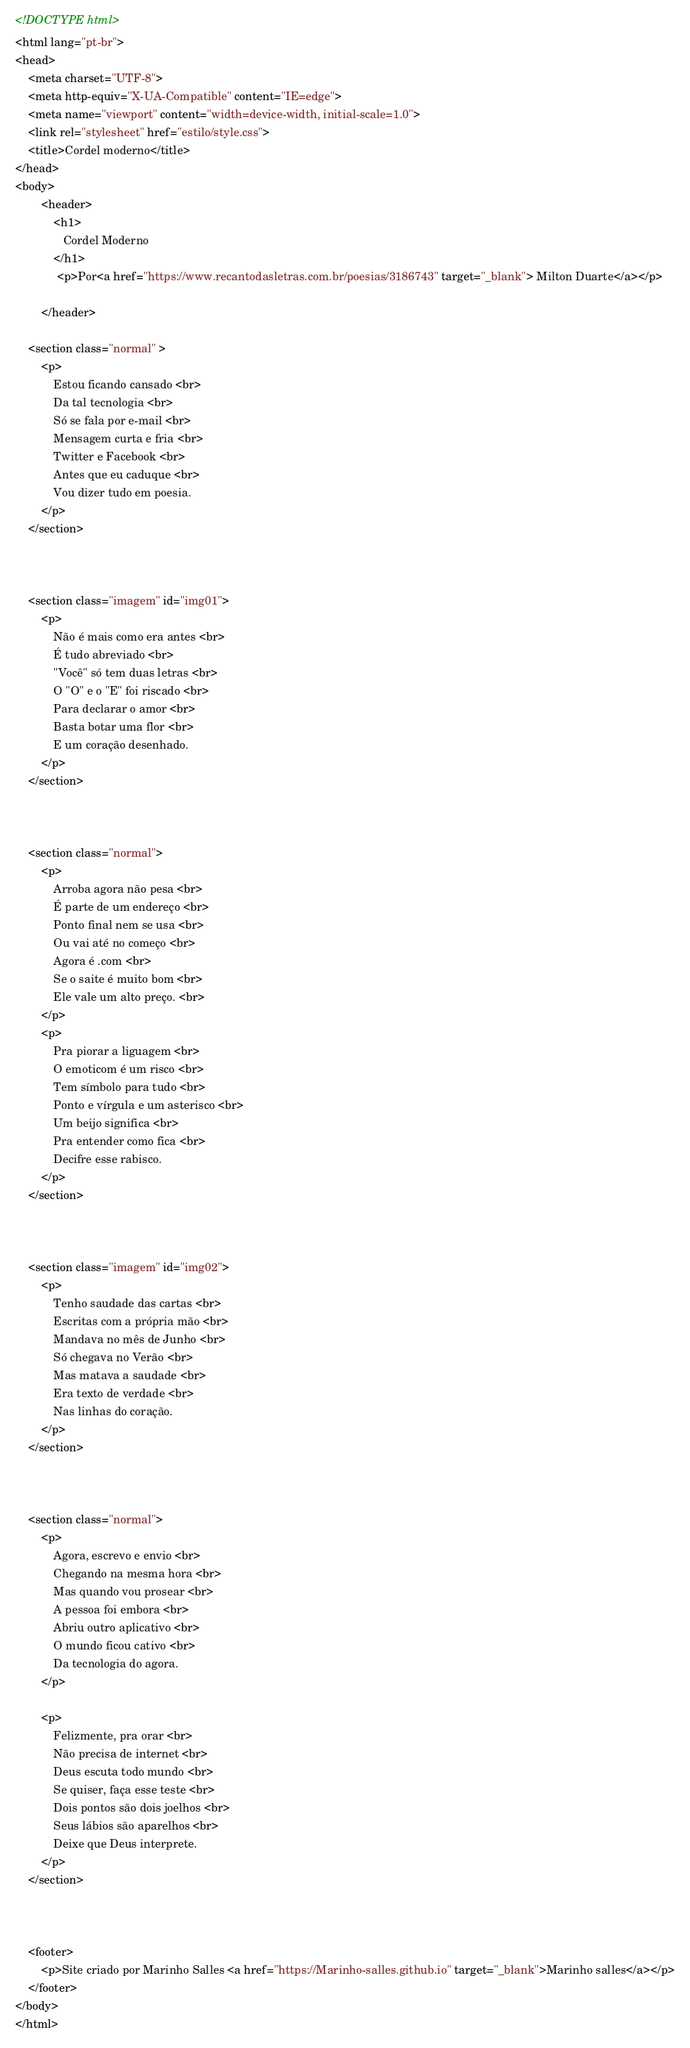Convert code to text. <code><loc_0><loc_0><loc_500><loc_500><_HTML_><!DOCTYPE html>
<html lang="pt-br">
<head>
    <meta charset="UTF-8">
    <meta http-equiv="X-UA-Compatible" content="IE=edge">
    <meta name="viewport" content="width=device-width, initial-scale=1.0">
    <link rel="stylesheet" href="estilo/style.css">
    <title>Cordel moderno</title>
</head>
<body>
        <header>
            <h1>
               Cordel Moderno
            </h1>
             <p>Por<a href="https://www.recantodasletras.com.br/poesias/3186743" target="_blank"> Milton Duarte</a></p>
             
        </header>

    <section class="normal" >
        <p>
            Estou ficando cansado <br>
            Da tal tecnologia <br>
            Só se fala por e-mail <br>
            Mensagem curta e fria <br>
            Twitter e Facebook <br>
            Antes que eu caduque <br>
            Vou dizer tudo em poesia.
        </p>
    </section>

    

    <section class="imagem" id="img01">
        <p>
            Não é mais como era antes <br>
            É tudo abreviado <br>
            "Você" só tem duas letras <br>
            O "O" e o "E" foi riscado <br>
            Para declarar o amor <br>
            Basta botar uma flor <br>
            E um coração desenhado.
        </p>
    </section>

    

    <section class="normal">
        <p>
            Arroba agora não pesa <br>
            É parte de um endereço <br>
            Ponto final nem se usa <br>
            Ou vai até no começo <br>
            Agora é .com <br>
            Se o saite é muito bom <br>
            Ele vale um alto preço. <br>
        </p>
        <p>
            Pra piorar a liguagem <br>
            O emoticom é um risco <br>
            Tem símbolo para tudo <br>
            Ponto e vírgula e um asterisco <br>
            Um beijo significa <br>
            Pra entender como fica <br>
            Decifre esse rabisco.
        </p>
    </section>

    

    <section class="imagem" id="img02">
        <p>
            Tenho saudade das cartas <br>
            Escritas com a própria mão <br>
            Mandava no mês de Junho <br>
            Só chegava no Verão <br>
            Mas matava a saudade <br>
            Era texto de verdade <br>
            Nas linhas do coração.
        </p>
    </section>

    

    <section class="normal">
        <p>
            Agora, escrevo e envio <br>
            Chegando na mesma hora <br>
            Mas quando vou prosear <br>
            A pessoa foi embora <br>
            Abriu outro aplicativo <br>
            O mundo ficou cativo <br>
            Da tecnologia do agora.
        </p>

        <p>
            Felizmente, pra orar <br>
            Não precisa de internet <br>
            Deus escuta todo mundo <br>
            Se quiser, faça esse teste <br>
            Dois pontos são dois joelhos <br>
            Seus lábios são aparelhos <br>
            Deixe que Deus interprete.
        </p>
    </section>

    

    <footer>
        <p>Site criado por Marinho Salles <a href="https://Marinho-salles.github.io" target="_blank">Marinho salles</a></p>
    </footer>
</body>
</html></code> 